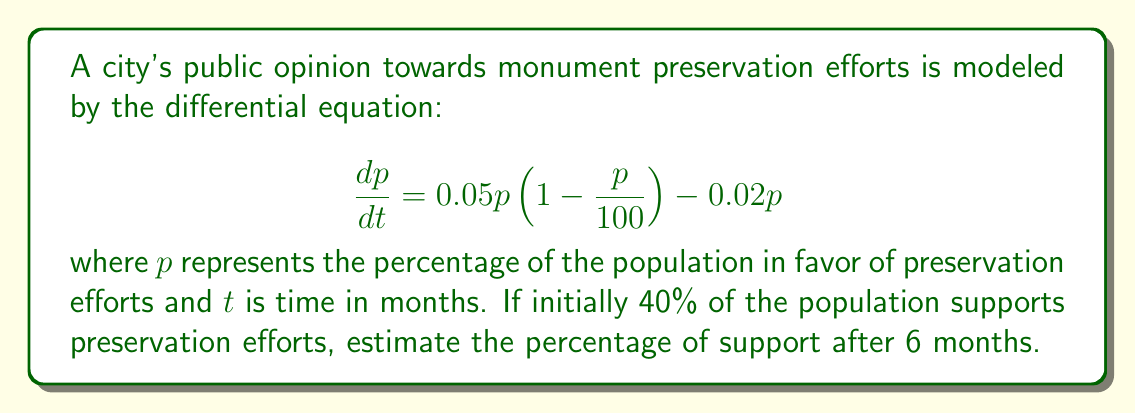Teach me how to tackle this problem. To solve this problem, we need to use the given first-order differential equation and initial condition:

1) The differential equation is in the form of a logistic growth model with an additional decay term:
   $$\frac{dp}{dt} = 0.05p(1-\frac{p}{100}) - 0.02p$$

2) This equation can be rewritten as:
   $$\frac{dp}{dt} = 0.05p - 0.0005p^2 - 0.02p = 0.03p - 0.0005p^2$$

3) This is a separable differential equation. However, solving it analytically is complex. Instead, we can use Euler's method to approximate the solution numerically.

4) Euler's method is given by:
   $$p_{n+1} = p_n + h \cdot f(t_n, p_n)$$
   where $h$ is the step size and $f(t,p) = 0.03p - 0.0005p^2$

5) Let's use a step size of $h = 1$ month. We need to iterate 6 times to reach 6 months:

   Initial: $p_0 = 40$
   
   Month 1: $p_1 = 40 + 1 \cdot (0.03 \cdot 40 - 0.0005 \cdot 40^2) = 40.8$
   
   Month 2: $p_2 = 40.8 + 1 \cdot (0.03 \cdot 40.8 - 0.0005 \cdot 40.8^2) = 41.57$
   
   Month 3: $p_3 = 41.57 + 1 \cdot (0.03 \cdot 41.57 - 0.0005 \cdot 41.57^2) = 42.30$
   
   Month 4: $p_4 = 42.30 + 1 \cdot (0.03 \cdot 42.30 - 0.0005 \cdot 42.30^2) = 42.99$
   
   Month 5: $p_5 = 42.99 + 1 \cdot (0.03 \cdot 42.99 - 0.0005 \cdot 42.99^2) = 43.64$
   
   Month 6: $p_6 = 43.64 + 1 \cdot (0.03 \cdot 43.64 - 0.0005 \cdot 43.64^2) = 44.25$

6) Therefore, after 6 months, approximately 44.25% of the population supports preservation efforts.
Answer: After 6 months, approximately 44.25% of the population supports preservation efforts. 